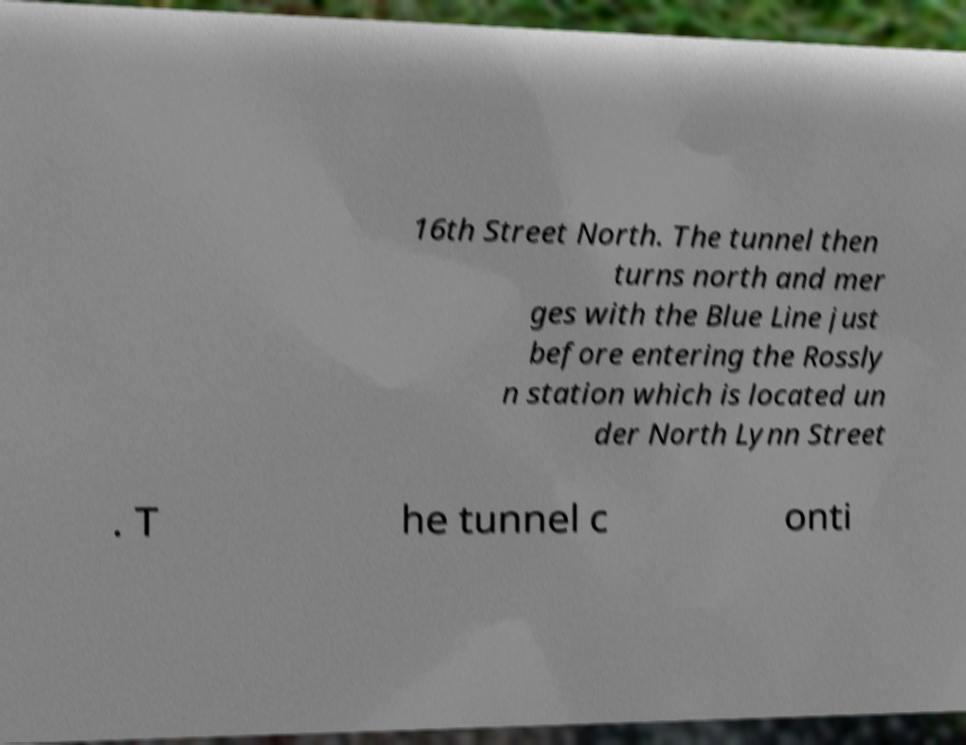I need the written content from this picture converted into text. Can you do that? 16th Street North. The tunnel then turns north and mer ges with the Blue Line just before entering the Rossly n station which is located un der North Lynn Street . T he tunnel c onti 